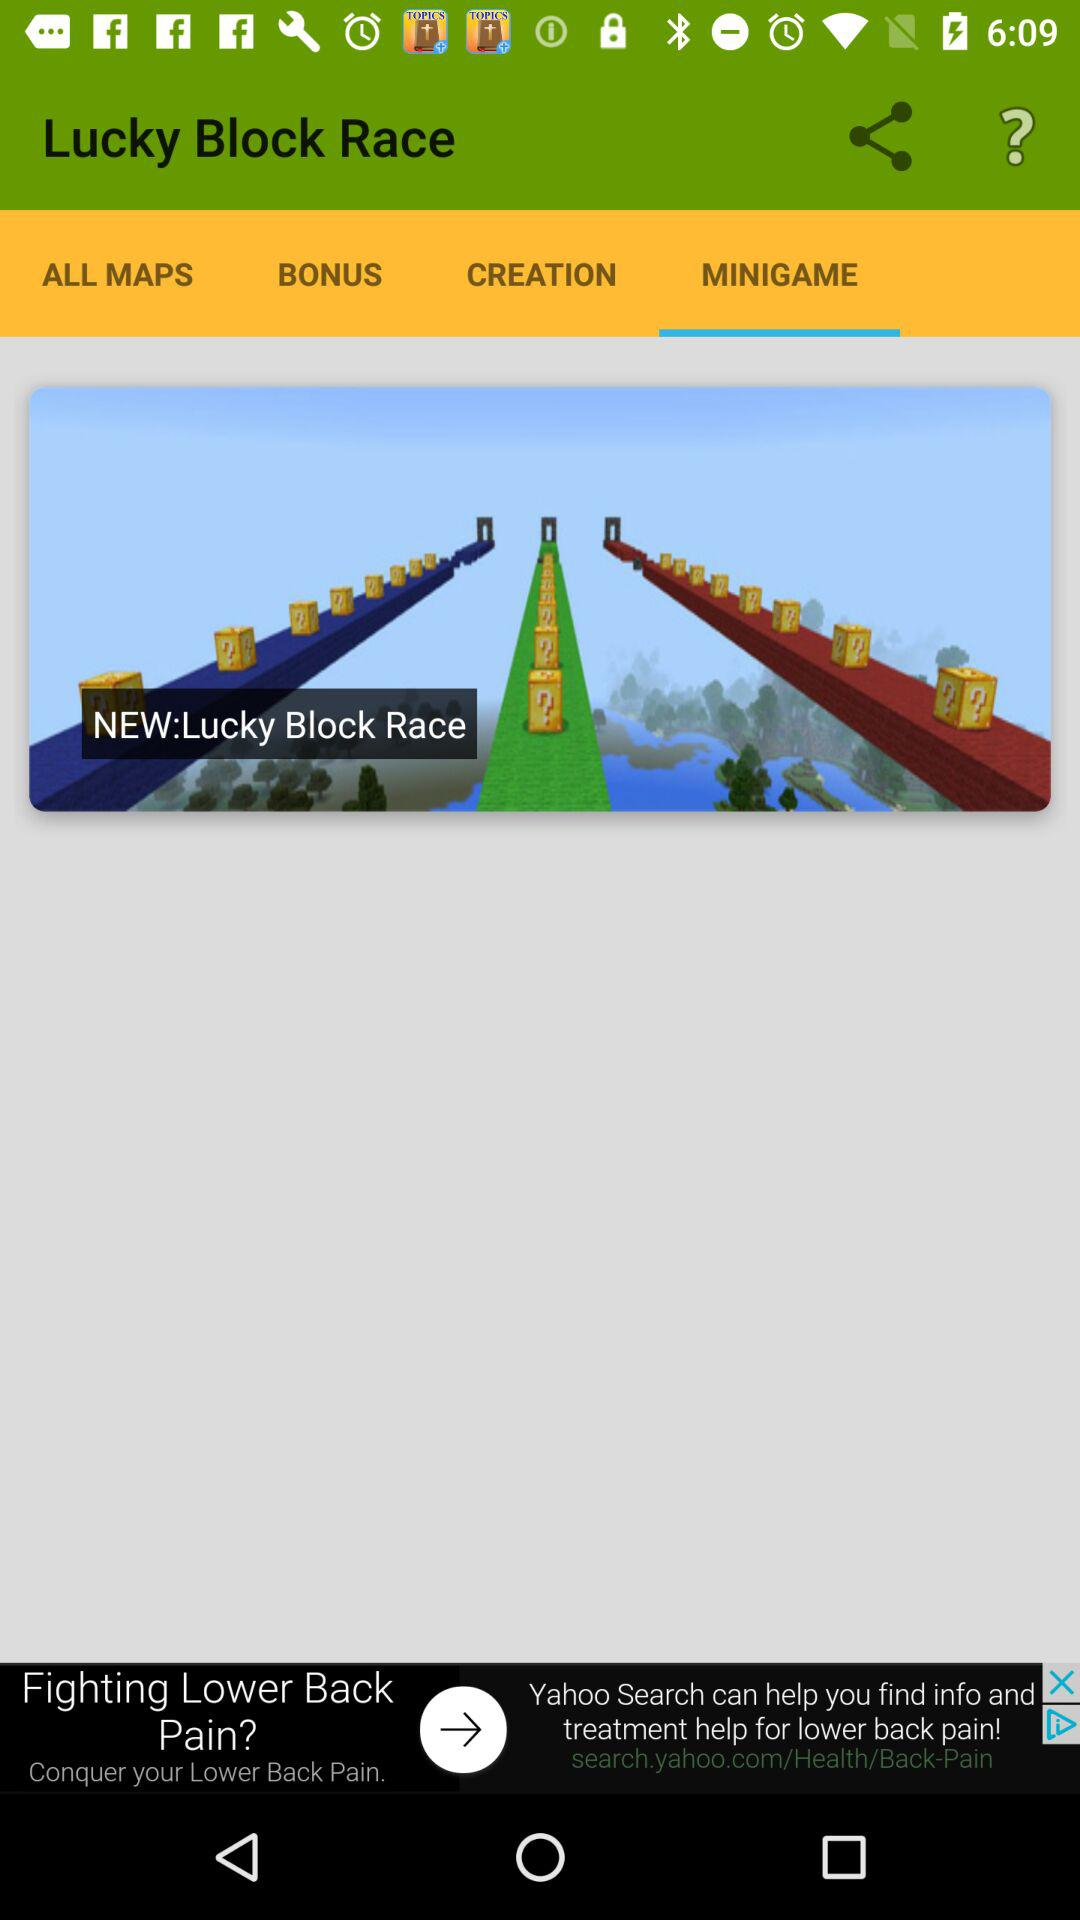What version of "Lucky Block Race" is being used?
When the provided information is insufficient, respond with <no answer>. <no answer> 